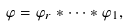<formula> <loc_0><loc_0><loc_500><loc_500>\varphi = \varphi _ { r } \ast \cdots \ast \varphi _ { 1 } ,</formula> 